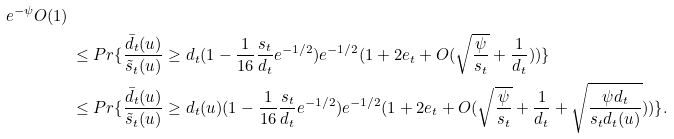Convert formula to latex. <formula><loc_0><loc_0><loc_500><loc_500>{ e ^ { - \psi } O ( 1 ) } \, \\ & \leq P r \{ \frac { \bar { d } _ { t } ( u ) } { \tilde { s } _ { t } ( u ) } \geq d _ { t } ( 1 - \frac { 1 } { 1 6 } \frac { s _ { t } } { d _ { t } } e ^ { - 1 / 2 } ) e ^ { - 1 / 2 } ( 1 + 2 e _ { t } + O ( \sqrt { \frac { \psi } { s _ { t } } } + \frac { 1 } { d _ { t } } ) ) \} \\ & \leq P r \{ \frac { \bar { d } _ { t } ( u ) } { \tilde { s } _ { t } ( u ) } \geq d _ { t } ( u ) ( 1 - \frac { 1 } { 1 6 } \frac { s _ { t } } { d _ { t } } e ^ { - 1 / 2 } ) e ^ { - 1 / 2 } ( 1 + 2 e _ { t } + O ( \sqrt { \frac { \psi } { s _ { t } } } + \frac { 1 } { d _ { t } } + \sqrt { \frac { \psi d _ { t } } { s _ { t } d _ { t } ( u ) } } ) ) \} .</formula> 